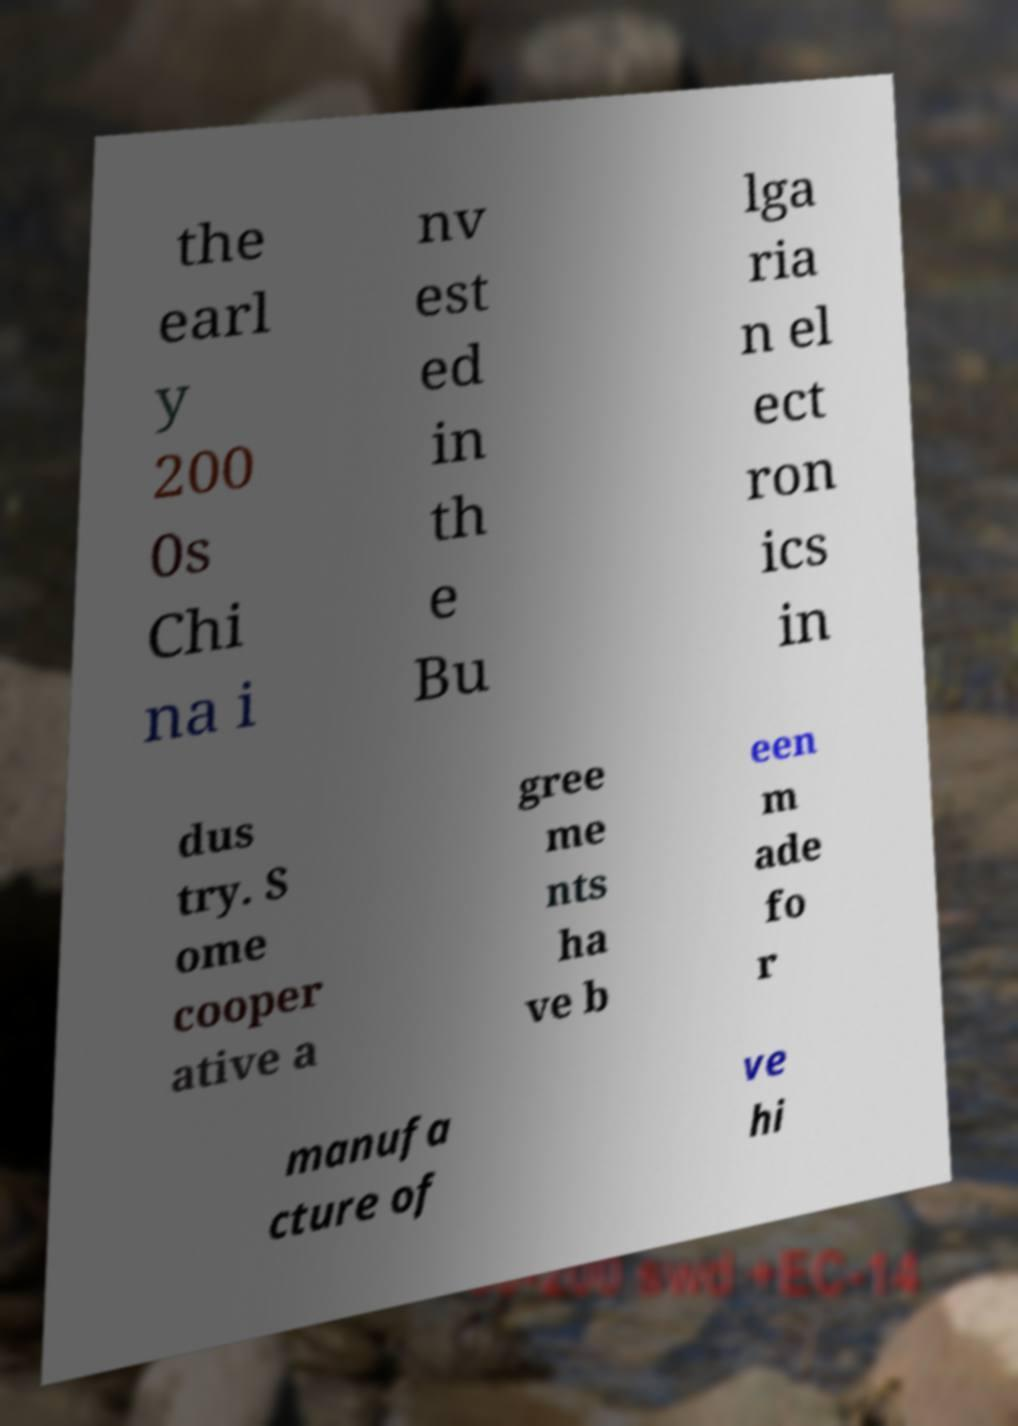Please identify and transcribe the text found in this image. the earl y 200 0s Chi na i nv est ed in th e Bu lga ria n el ect ron ics in dus try. S ome cooper ative a gree me nts ha ve b een m ade fo r manufa cture of ve hi 